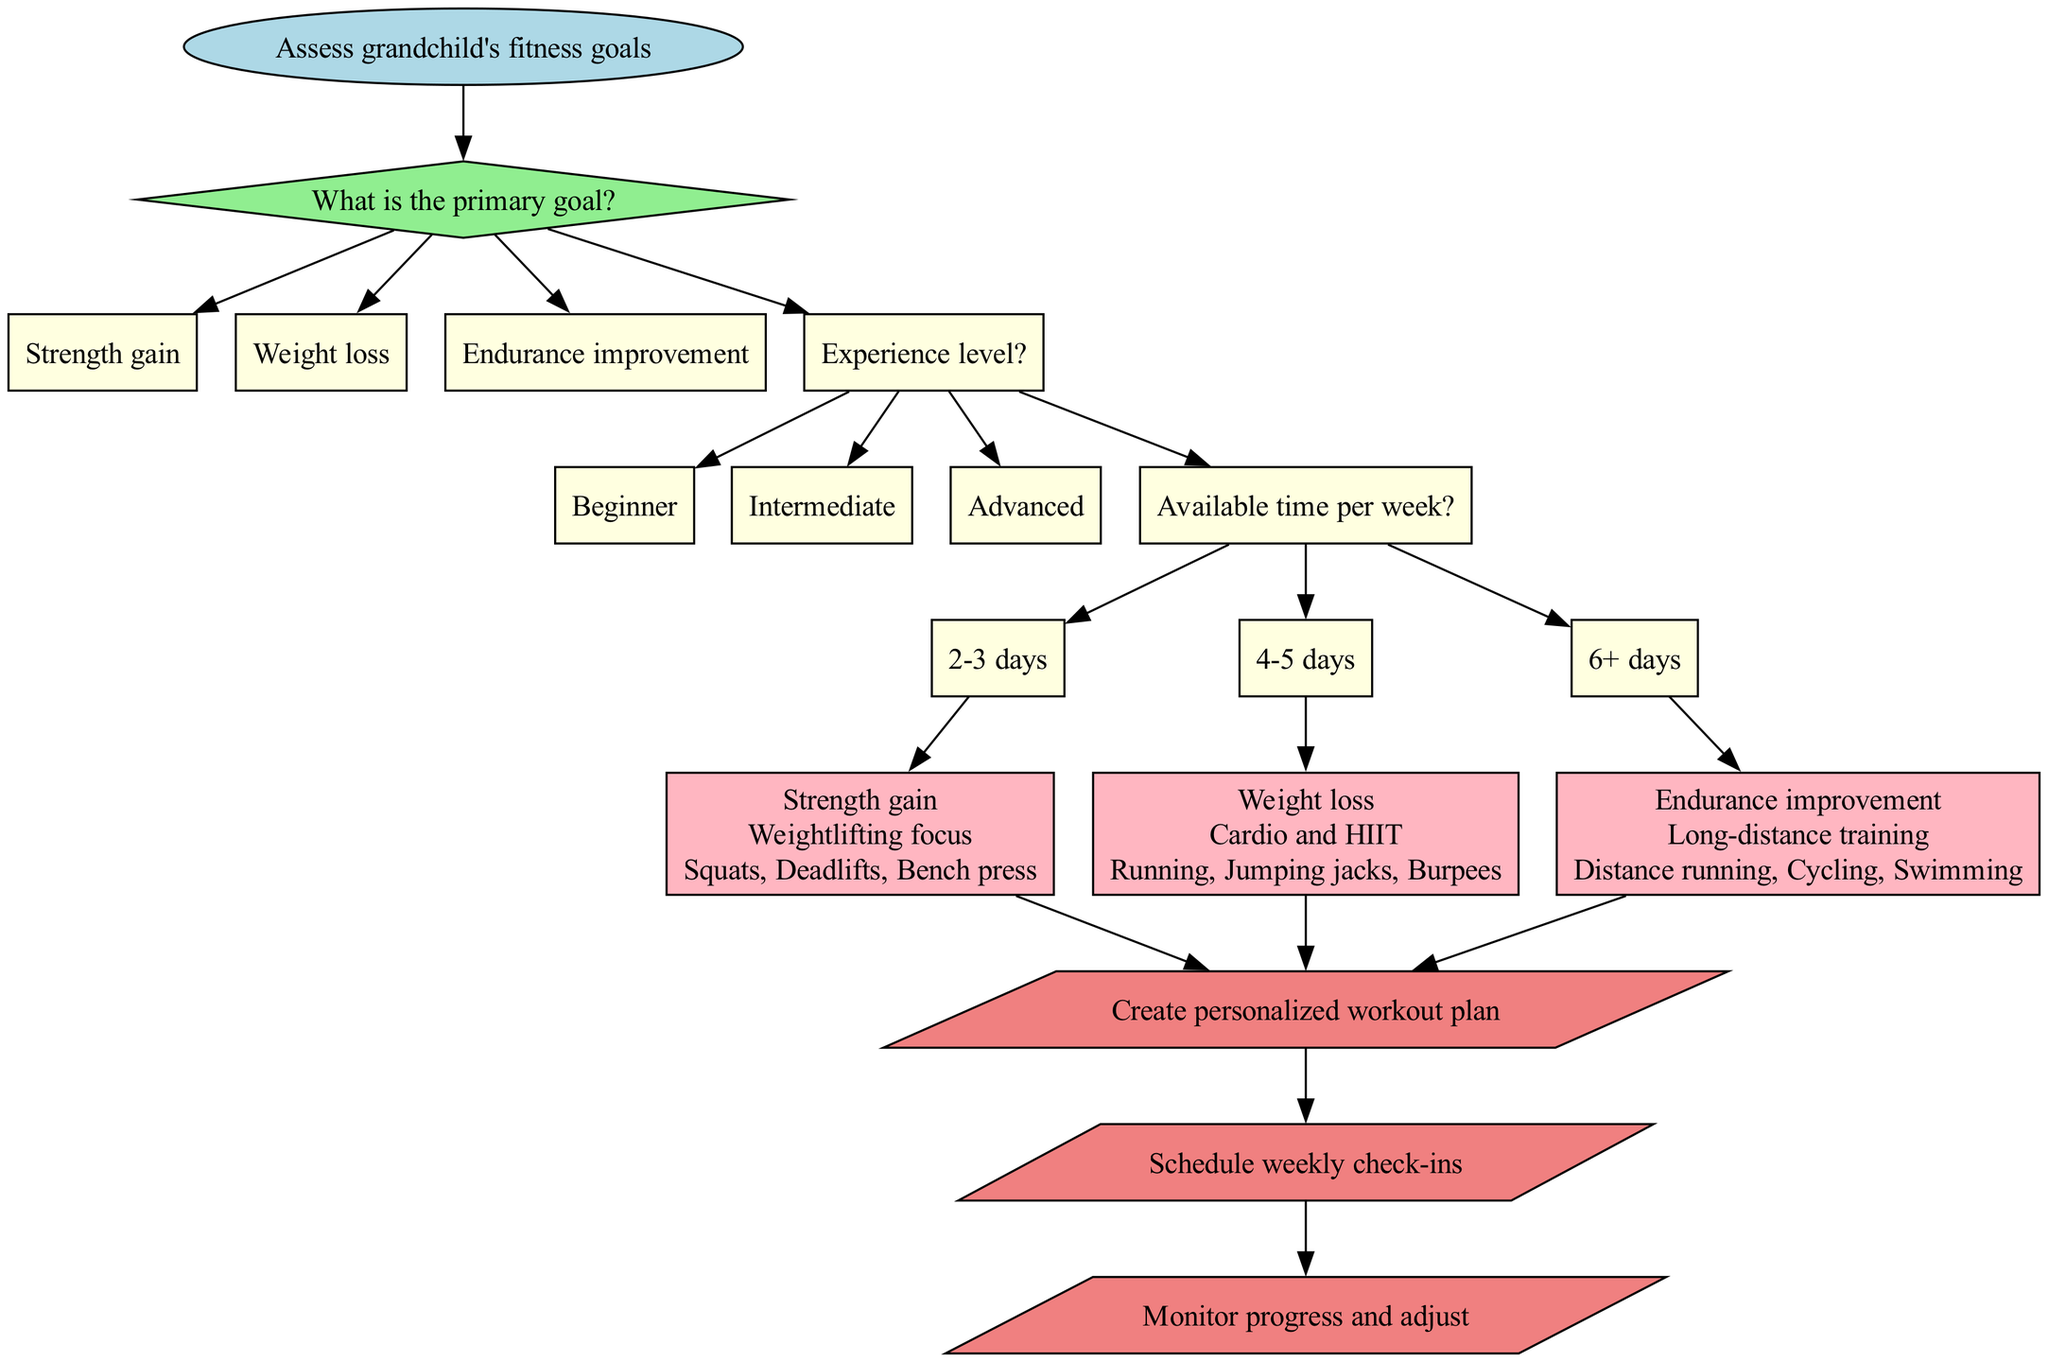What is the primary goal in the first decision node? The primary goal is presented in the first decision node as a question. It lists three options: Strength gain, Weight loss, and Endurance improvement. Among these, the primary goal from the diagram does not specify anything further but implies you need to choose from these options.
Answer: Strength gain, Weight loss, Endurance improvement How many recommendations are provided in the diagram? The diagram includes a section for recommendations, detailing three specific programs based on different goals. By counting these distinct recommendation nodes, you find that there are three programs offered: one for each primary goal.
Answer: 3 What shape is used for the final steps in the diagram? The final steps of the flowchart are presented in a specific shape, which visually distinguishes them from other sections. In this instance, the parallelogram shape has been designated for the final steps, highlighting their importance.
Answer: Parallelogram What exercises are suggested for weight loss? In the recommendation section related to weight loss, the diagram provides set exercises that are specifically tailored for individuals focusing on this goal. By inspecting this node, one can clearly find the exercises listed directly associated with the weight loss program.
Answer: Running, Jumping jacks, Burpees Which experience level leads to strength gain recommendations? The path through the diagram that starts with the experience level decision node determines the flow towards the recommendation. The recommendation for strength gain is connected to both experience level and the primary goal, where it is implied that strength gain can cater to different experience levels.
Answer: Beginner, Intermediate, Advanced Which decision node leads to the cardio and HIIT recommendation? The path to the cardio and HIIT recommendation can be traced back through the decision nodes where specific options flow through. The key is identifying the path through the primary goal's decision leading you directly into the recommendation for weight loss, which is associated with cardio and HIIT.
Answer: Weight loss What can you expect to do after creating a personalized workout plan? The diagram lists clear final steps after identifying the appropriate program. The action that follows this creation is critical for maintaining progress and success in the workout regime. As such, it leads to the next logical step after establishing the workout plan.
Answer: Schedule weekly check-ins Which option in the second decision relates to the number of days available for workout? The second decision node pertains to the options regarding available time for workouts. This option helps guide towards a personalized program. By analyzing the flow of nodes, you can identify that this decision specifically addresses availability, leading to different personalization routes based on the number of workout days.
Answer: 2-3 days, 4-5 days, 6+ days 